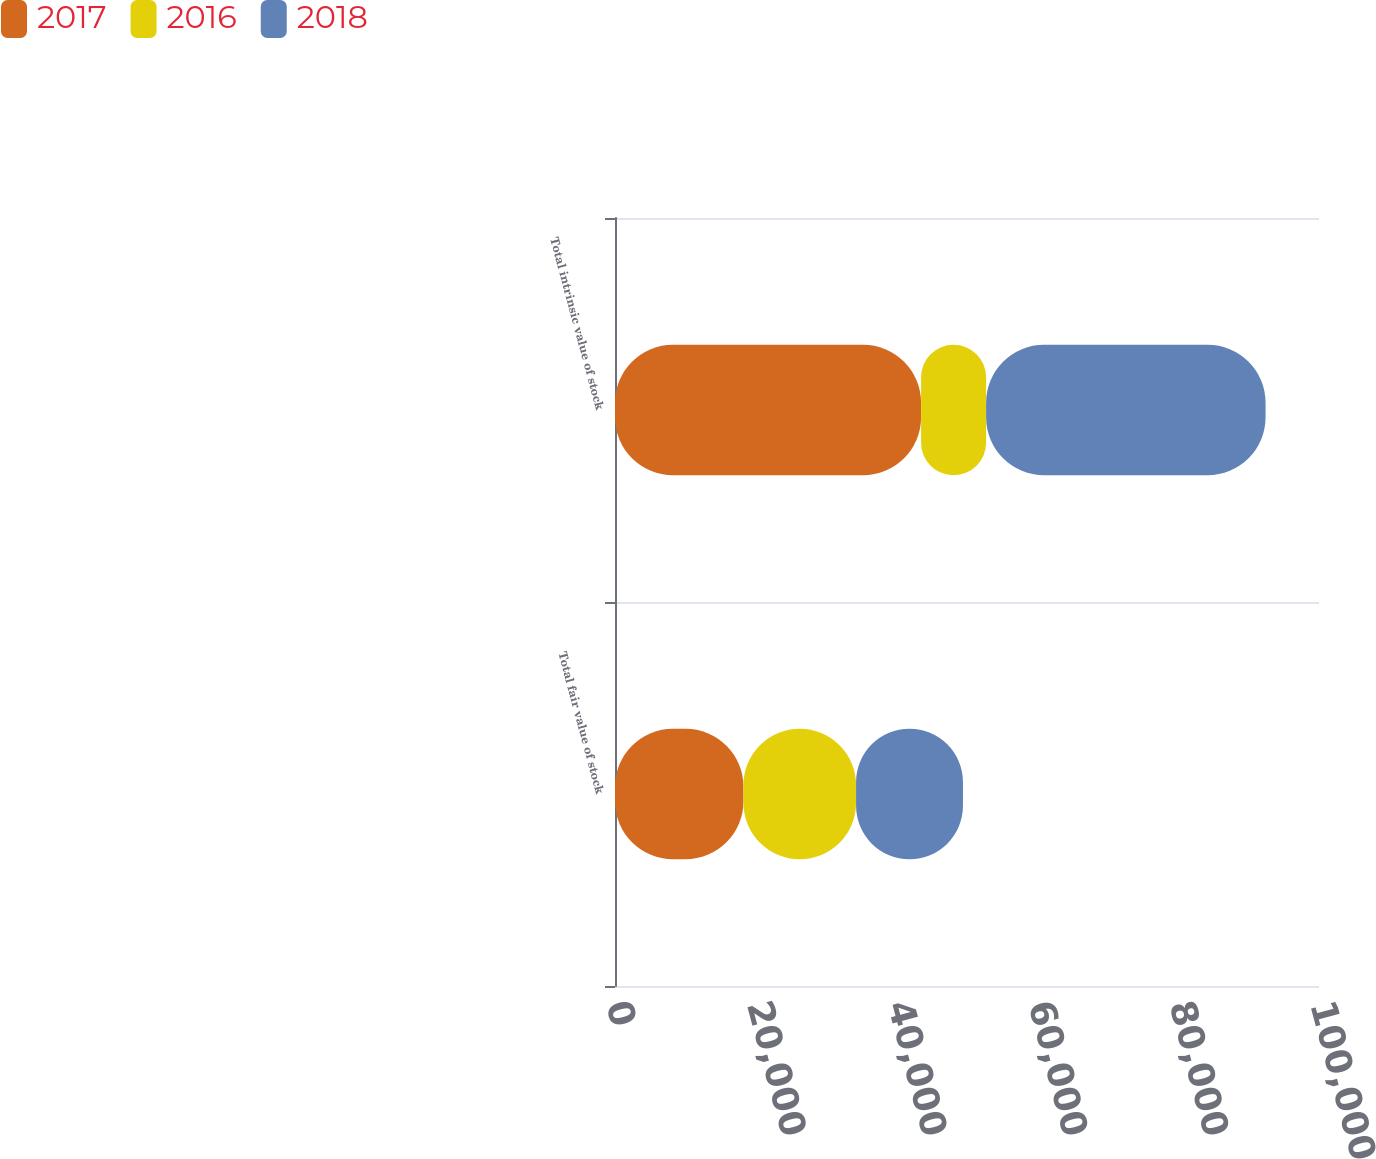Convert chart to OTSL. <chart><loc_0><loc_0><loc_500><loc_500><stacked_bar_chart><ecel><fcel>Total fair value of stock<fcel>Total intrinsic value of stock<nl><fcel>2017<fcel>18247<fcel>43476<nl><fcel>2016<fcel>15996<fcel>9237<nl><fcel>2018<fcel>15184<fcel>39696<nl></chart> 